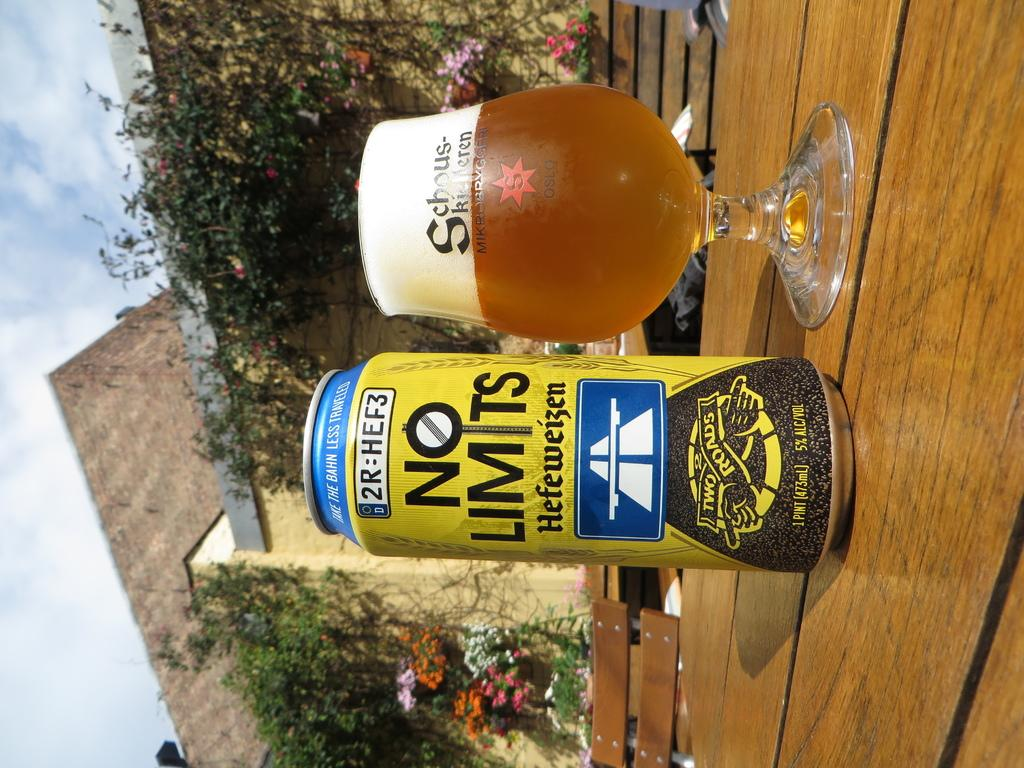<image>
Create a compact narrative representing the image presented. A No Limits beer can sits next to a filled glass. 